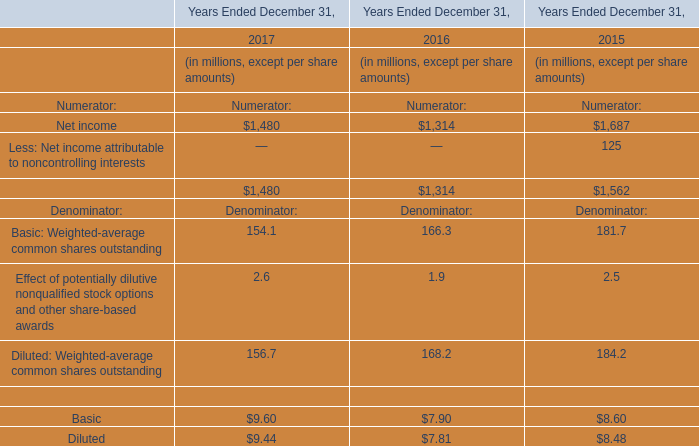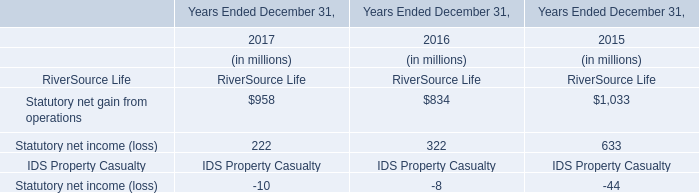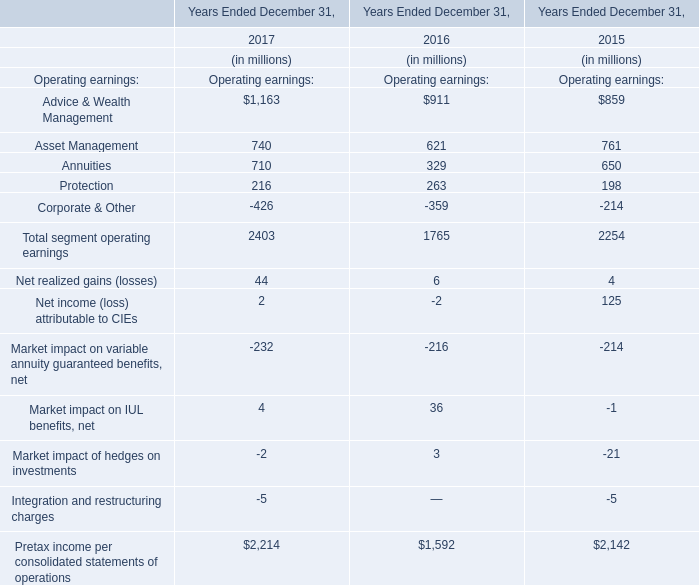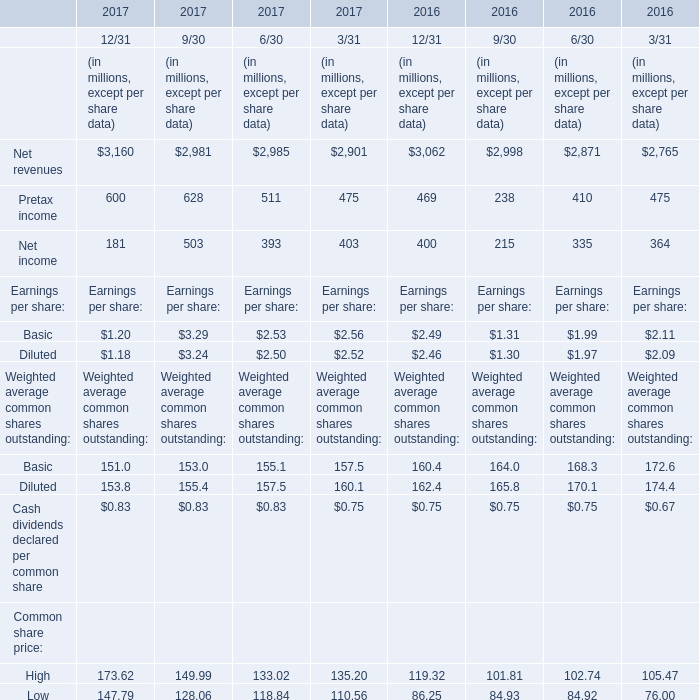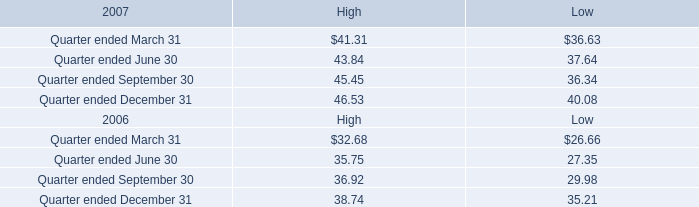What's the total amount of the segment operating earnings in the years where Market impact of hedges on investments is greater than 2? (in million) 
Computations: ((((911 + 621) + 329) + 263) - 359)
Answer: 1765.0. 